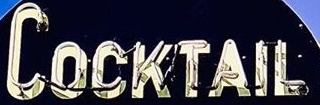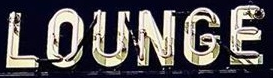What text appears in these images from left to right, separated by a semicolon? COCKTAIL; LOUNGE 